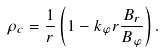Convert formula to latex. <formula><loc_0><loc_0><loc_500><loc_500>\rho _ { c } = \frac { 1 } { r } \left ( 1 - k _ { \varphi } r \frac { B _ { r } } { B _ { \varphi } } \right ) .</formula> 